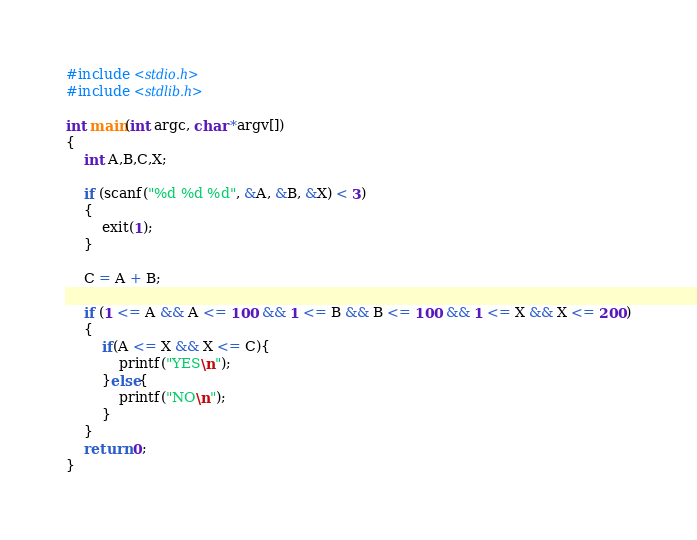Convert code to text. <code><loc_0><loc_0><loc_500><loc_500><_C_>#include <stdio.h>
#include <stdlib.h>

int main(int argc, char *argv[])
{
    int A,B,C,X;

    if (scanf("%d %d %d", &A, &B, &X) < 3)
    {
        exit(1);
    }

    C = A + B;

    if (1 <= A && A <= 100 && 1 <= B && B <= 100 && 1 <= X && X <= 200)
    {
        if(A <= X && X <= C){
            printf("YES\n");
        }else{
            printf("NO\n");
        }
    }
    return 0;
}</code> 